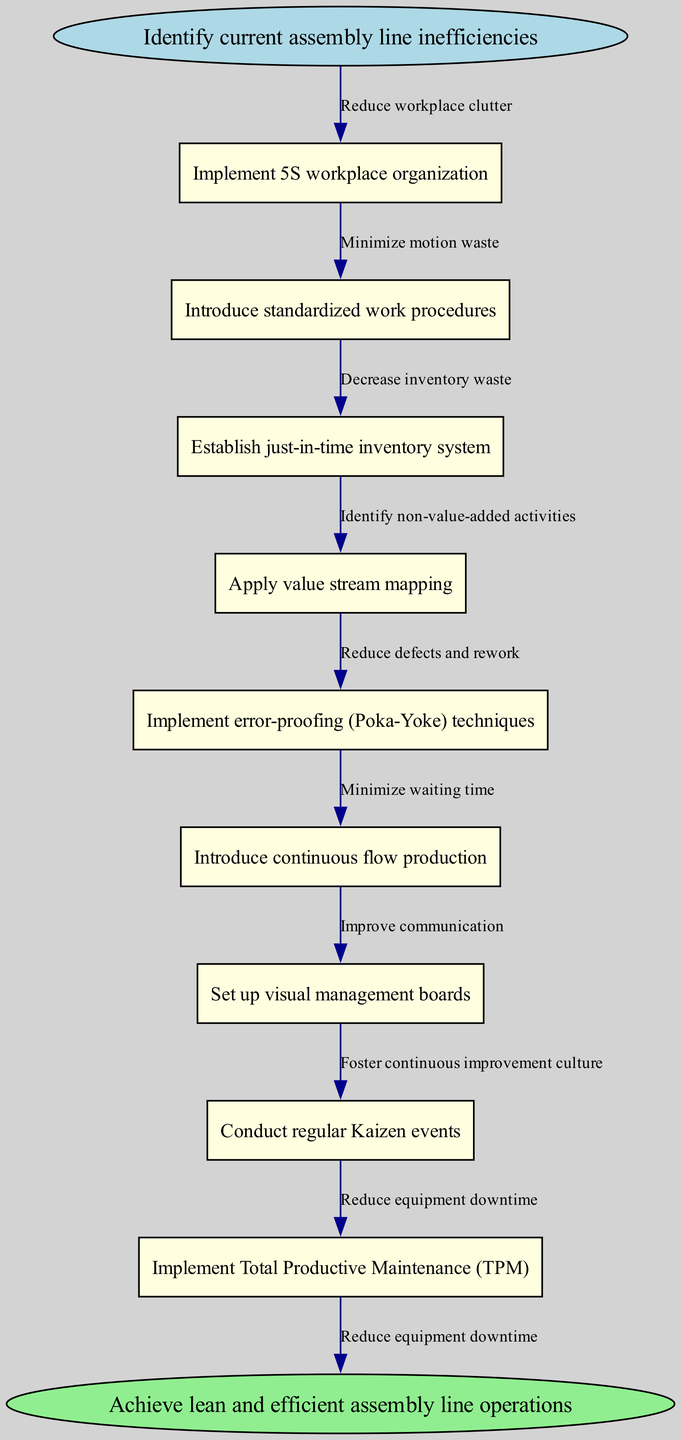What is the starting point of the pathway? The pathway begins with identifying current assembly line inefficiencies, which is represented as the start node in the diagram.
Answer: Identify current assembly line inefficiencies How many nodes are present in the diagram? By counting the individual nodes in the diagram, including the start and end nodes, there are a total of ten nodes.
Answer: Ten What technique involves organizing the workplace? The technique that focuses on workplace organization is known as the 5S workplace organization method.
Answer: Implement 5S workplace organization Which principle aims to reduce defects? The principle aimed at reducing defects and rework in the assembly line process is error-proofing, also known as Poka-Yoke techniques.
Answer: Implement error-proofing (Poka-Yoke) techniques What is the relationship between the start node and the first node? The relationship is that the start node leads directly to the first node, which is about implementing the 5S workplace organization, indicating the first step in the process.
Answer: Reduce workplace clutter What end goal is represented in the diagram? The end goal depicted in the diagram is achieving lean and efficient assembly line operations, which signifies the successful result of following the clinical pathway.
Answer: Achieve lean and efficient assembly line operations How does the pathway suggest minimizing waiting time? The pathway indicates minimizing waiting time by introducing continuous flow production, which helps maintain a steady workflow and eliminates downtime.
Answer: Introduce continuous flow production What is the flow from the implementation of standardized work procedures? The flow from implementing standardized work procedures leads to minimizing motion waste, connecting improved operating procedures to reduced unnecessary movements.
Answer: Minimize motion waste Which continuous improvement method is indicated in the pathway? The pathway mentions conducting regular Kaizen events, a method focused on ongoing, incremental improvements in the workflow.
Answer: Conduct regular Kaizen events 